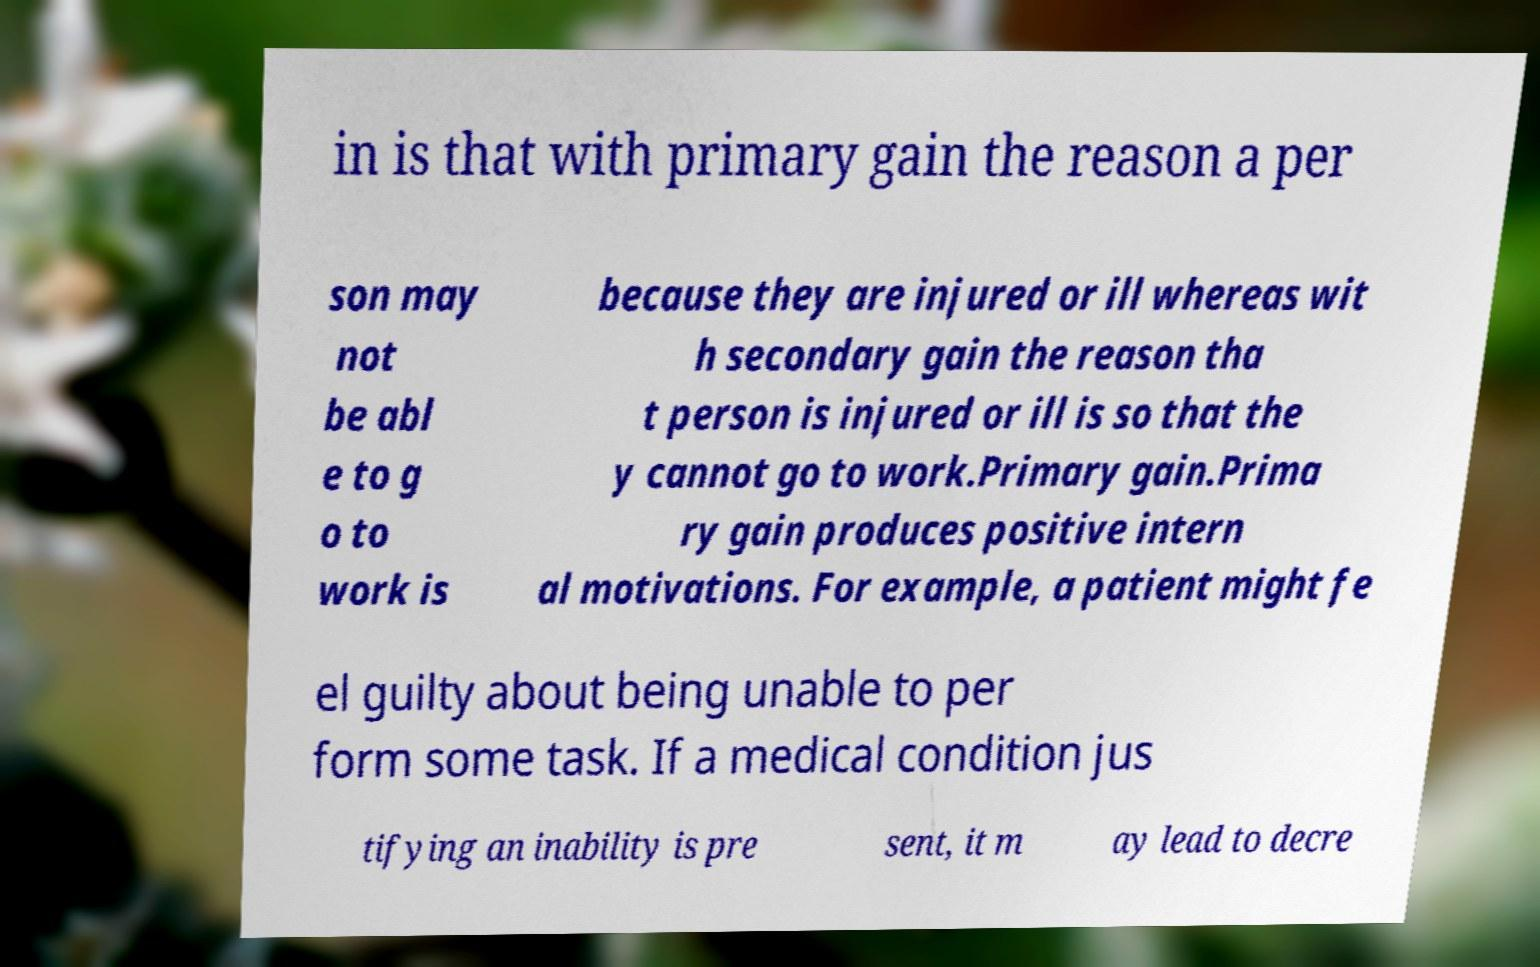I need the written content from this picture converted into text. Can you do that? in is that with primary gain the reason a per son may not be abl e to g o to work is because they are injured or ill whereas wit h secondary gain the reason tha t person is injured or ill is so that the y cannot go to work.Primary gain.Prima ry gain produces positive intern al motivations. For example, a patient might fe el guilty about being unable to per form some task. If a medical condition jus tifying an inability is pre sent, it m ay lead to decre 